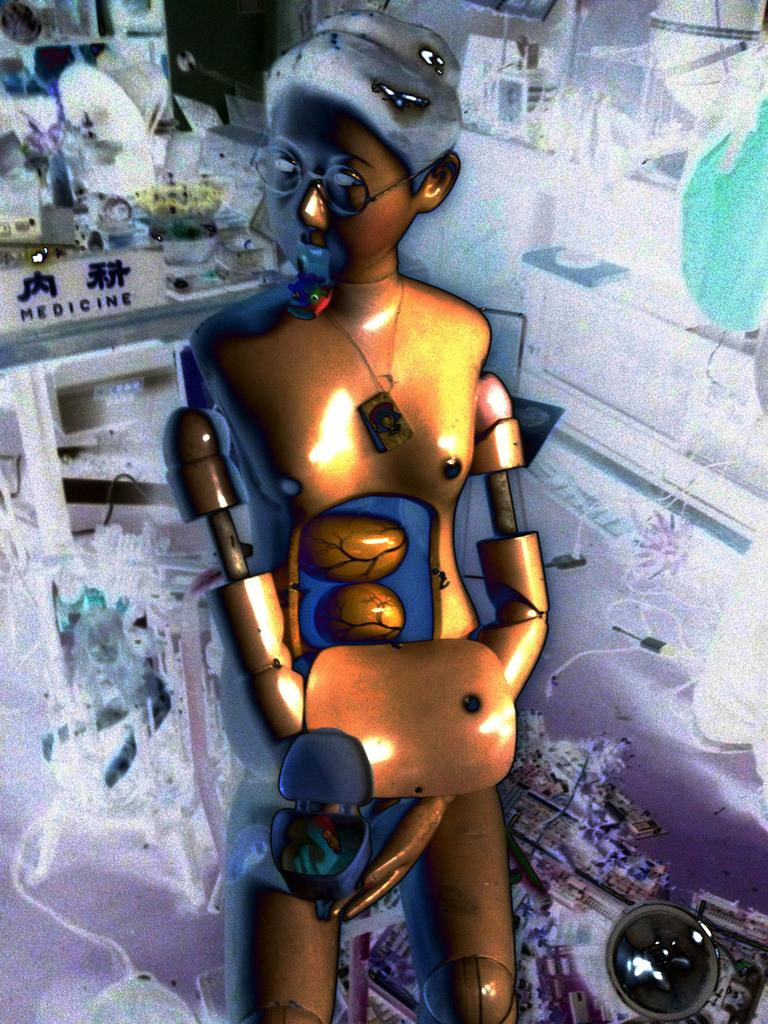What is the main object in the image? There is a toy in the image. Can you describe the toy's appearance? The toy is yellow and black in color. What can be seen in the background of the image? There are objects visible in the background. How is the image lit? There is white color lighting in the image. What is the chance of winning a land in space in the image? There is no reference to winning a land in space in the image; it features a yellow and black toy with objects visible in the background and white color lighting. 